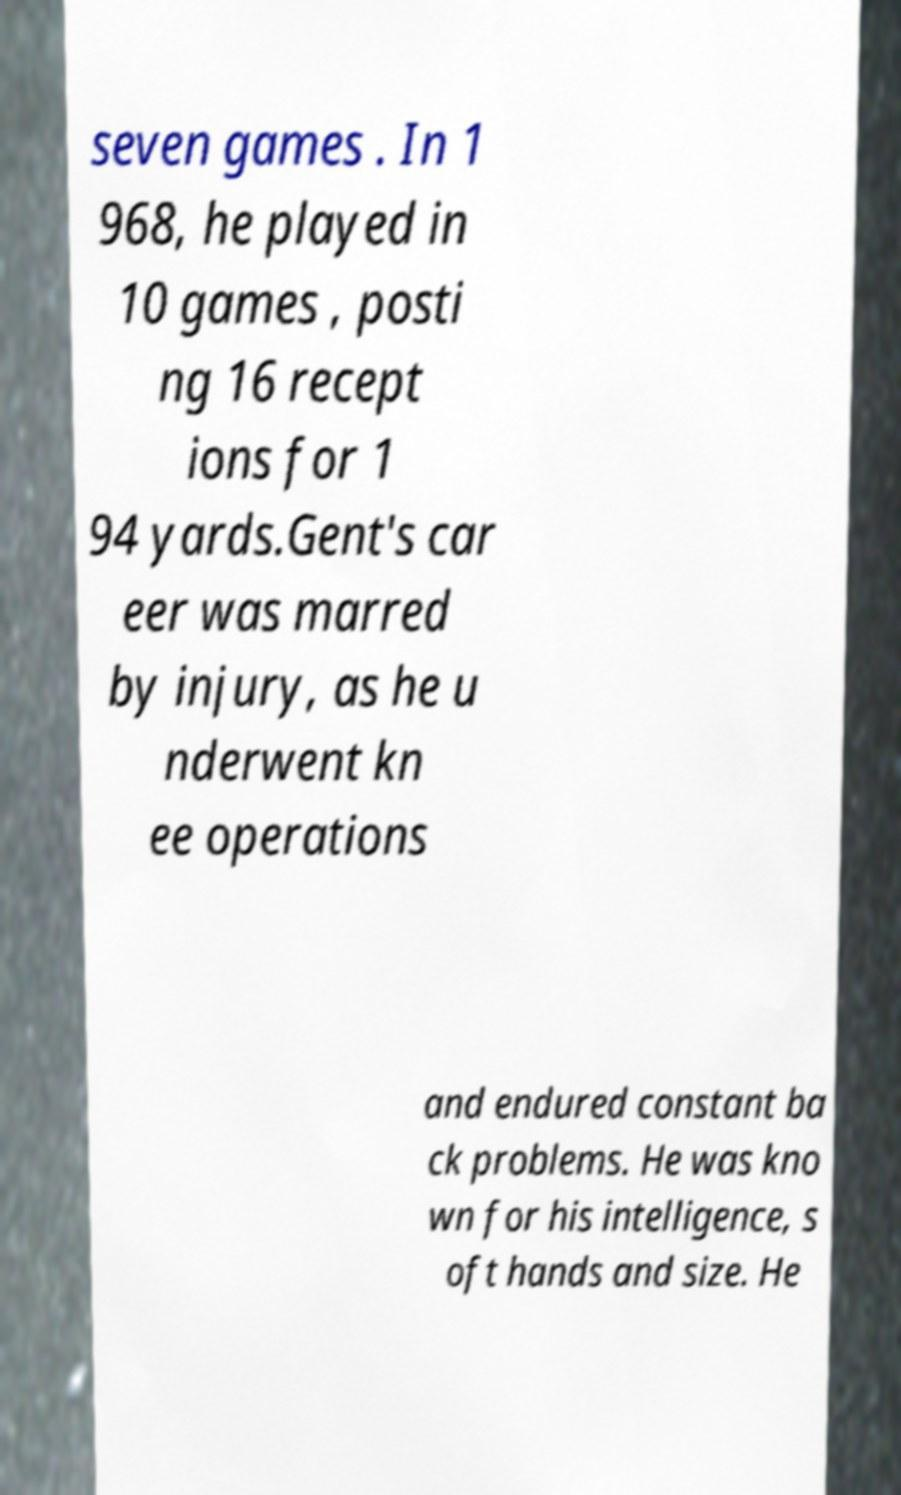Please read and relay the text visible in this image. What does it say? seven games . In 1 968, he played in 10 games , posti ng 16 recept ions for 1 94 yards.Gent's car eer was marred by injury, as he u nderwent kn ee operations and endured constant ba ck problems. He was kno wn for his intelligence, s oft hands and size. He 